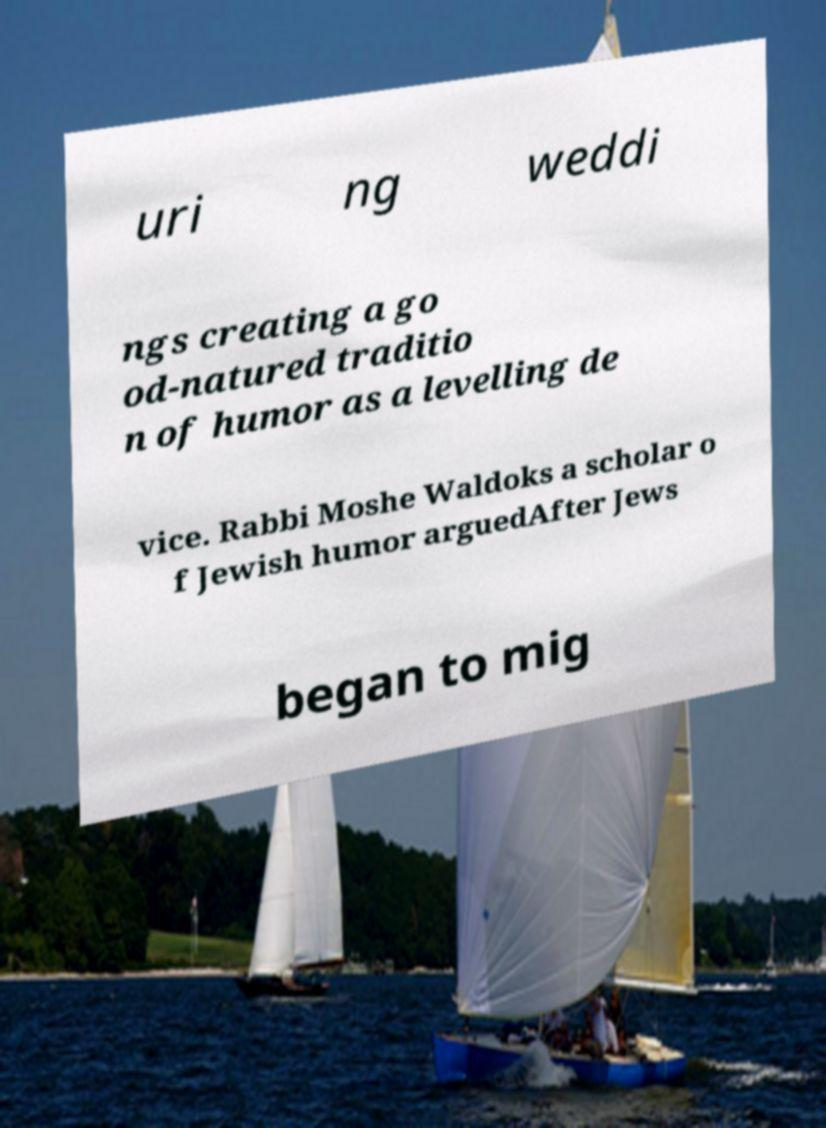What messages or text are displayed in this image? I need them in a readable, typed format. uri ng weddi ngs creating a go od-natured traditio n of humor as a levelling de vice. Rabbi Moshe Waldoks a scholar o f Jewish humor arguedAfter Jews began to mig 